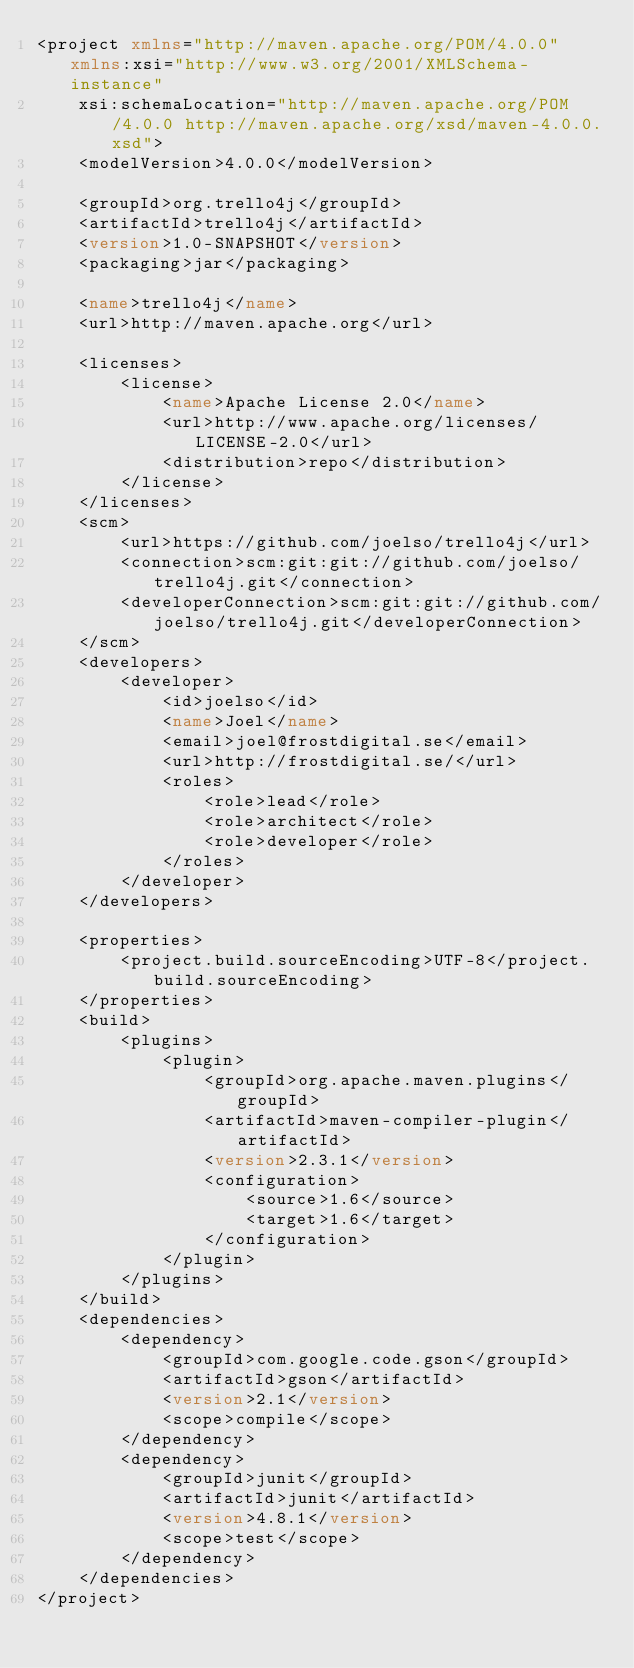<code> <loc_0><loc_0><loc_500><loc_500><_XML_><project xmlns="http://maven.apache.org/POM/4.0.0" xmlns:xsi="http://www.w3.org/2001/XMLSchema-instance"
	xsi:schemaLocation="http://maven.apache.org/POM/4.0.0 http://maven.apache.org/xsd/maven-4.0.0.xsd">
	<modelVersion>4.0.0</modelVersion>

	<groupId>org.trello4j</groupId>
	<artifactId>trello4j</artifactId>
	<version>1.0-SNAPSHOT</version>
	<packaging>jar</packaging>

	<name>trello4j</name>
	<url>http://maven.apache.org</url>

	<licenses>
		<license>
			<name>Apache License 2.0</name>
			<url>http://www.apache.org/licenses/LICENSE-2.0</url>
			<distribution>repo</distribution>
		</license>
	</licenses>
	<scm>
		<url>https://github.com/joelso/trello4j</url>
		<connection>scm:git:git://github.com/joelso/trello4j.git</connection>
		<developerConnection>scm:git:git://github.com/joelso/trello4j.git</developerConnection>
	</scm>
	<developers>
		<developer>
			<id>joelso</id>
			<name>Joel</name>
			<email>joel@frostdigital.se</email>
			<url>http://frostdigital.se/</url>
			<roles>
				<role>lead</role>
				<role>architect</role>
				<role>developer</role>
			</roles>
		</developer>
	</developers>

	<properties>
		<project.build.sourceEncoding>UTF-8</project.build.sourceEncoding>
	</properties>
	<build>
		<plugins>
			<plugin>
				<groupId>org.apache.maven.plugins</groupId>
				<artifactId>maven-compiler-plugin</artifactId>
				<version>2.3.1</version>
				<configuration>
					<source>1.6</source>
					<target>1.6</target>
				</configuration>
			</plugin>
		</plugins>
	</build>
	<dependencies>
		<dependency>
			<groupId>com.google.code.gson</groupId>
			<artifactId>gson</artifactId>
			<version>2.1</version>
			<scope>compile</scope>
		</dependency>
		<dependency>
			<groupId>junit</groupId>
			<artifactId>junit</artifactId>
			<version>4.8.1</version>
			<scope>test</scope>
		</dependency>
	</dependencies>
</project>
</code> 